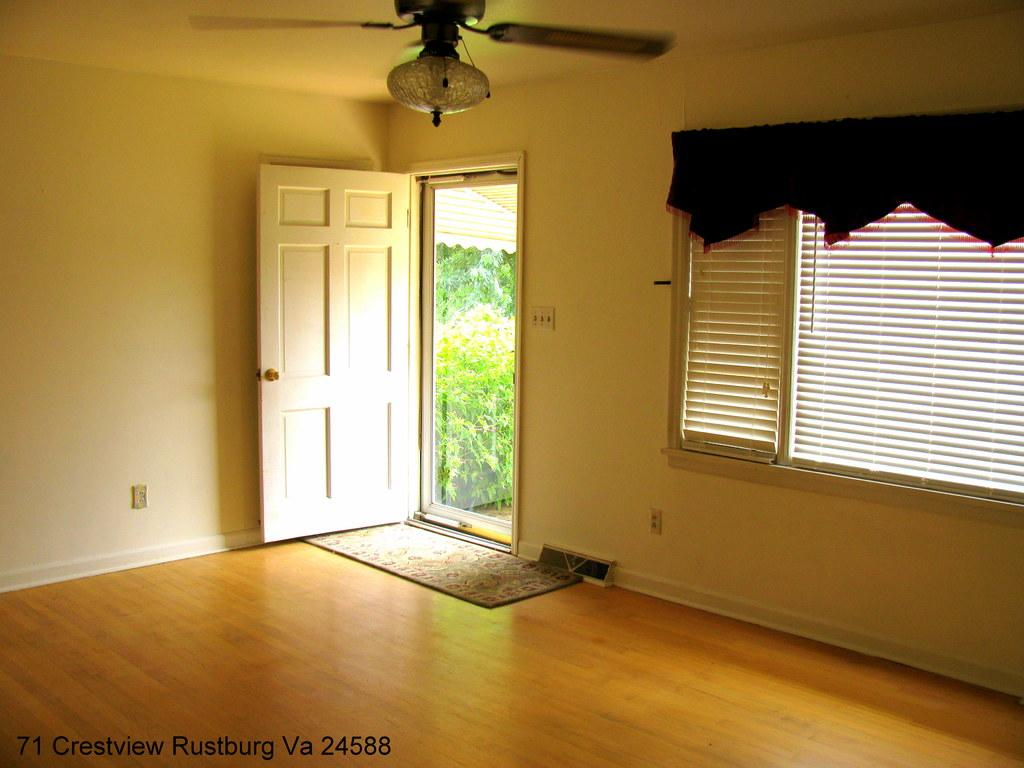What type of architectural feature can be seen in the image? There is a wall in the image. What is a feature that allows light and air to enter the room? There is a window in the image. What is used to cover the window? There is a curtain associated with the window. What is another entry point to the room? There is a door in the image. What device is present to provide air circulation? There is a fan in the image. What is placed near the door for cleaning shoes? There is a doormat in the image. What can be read in the image? There is text visible in the image. What type of greenery is present in the image? There are plants in the image. What type of larger vegetation is visible in the image? There are trees visible in the image. What type of space might the image depict? The image may have been taken in a hall. How many desks are visible in the image? There are no desks present in the image. What is the fifth item mentioned in the image? The facts provided do not list items in a specific order, so there is no "fifth" item. How many family members can be seen in the image? There is no reference to any family members in the image. 